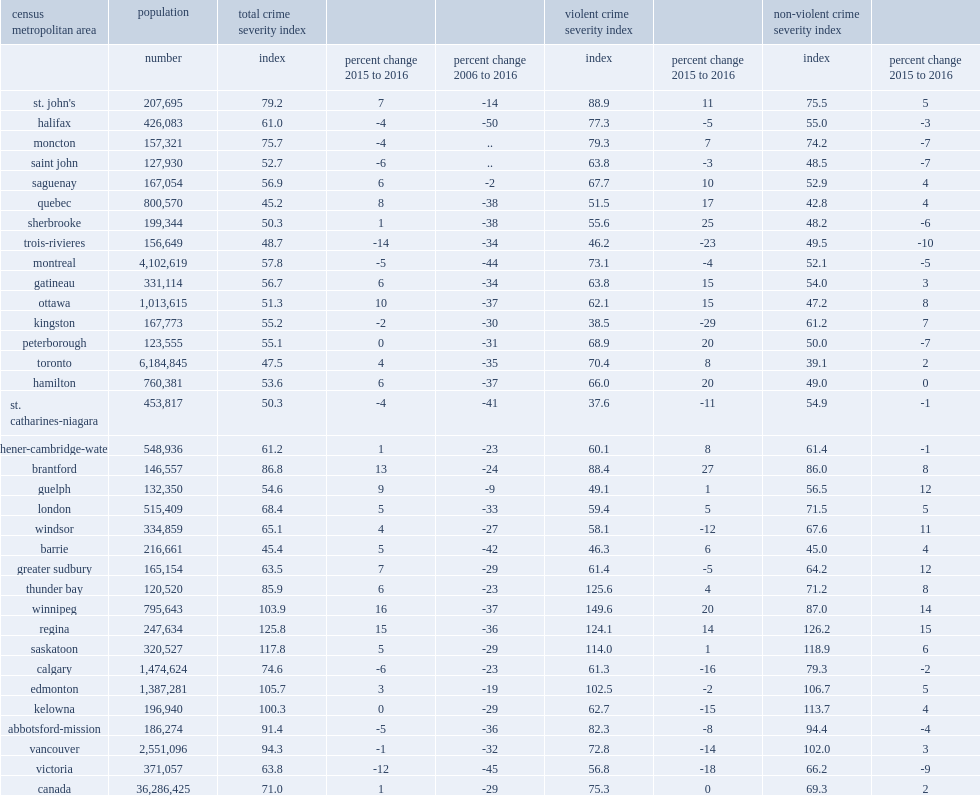In 2016,how many percentage points has regina increased in the non-violent csi index? 15.0. In 2016,how many percentage points has winnipeg increased in the non-violent csi index ? 14.0. In 2016,how many percentage points has greater sudbury increased in the non-violent csi index? 12.0. In 2016,how many percentage points has guelph increased in the non-violent csi index? 12.0. In 2016,how many percentage points has trois-rivieres reported decreases to their non-violent csi? 10. In 2016,how many percentage points has victoria reported decreases to their non-violent csi? 9. Between 2015 and 2016, how many canada's census metropolitan areas (cmas) reported increases in their crime severity index (csi)? 20. In 2016,how many percentage points has winnipeg recorded increases in csi? 16.0. In 2016,how many percentage points has regina recorded increases in csi? 15.0. In 2016,how many percentage points has brantford recorded increases in csi? 13.0. In 2016,how many percentage points has ottawa recorded increases in csi? 10.0. In 2016,how many percentage points has quebec recorded increases in csi? 8.0. In 2016,how many percentage points has calgary recorded declines in csi in 2016? 6. In 2016,how many percentage points has edmonton reported increases in csi? 3.0. In 2016,how many csis were recorded in edmonton in 2016? 105.7. In 2016,how many csis were recorded in kelowna? 100.3. In 2016,how many csis were recorded in vancouver? 94.3. In 2016,how many csis were recorded in abbotsford-mission? 91.4. 